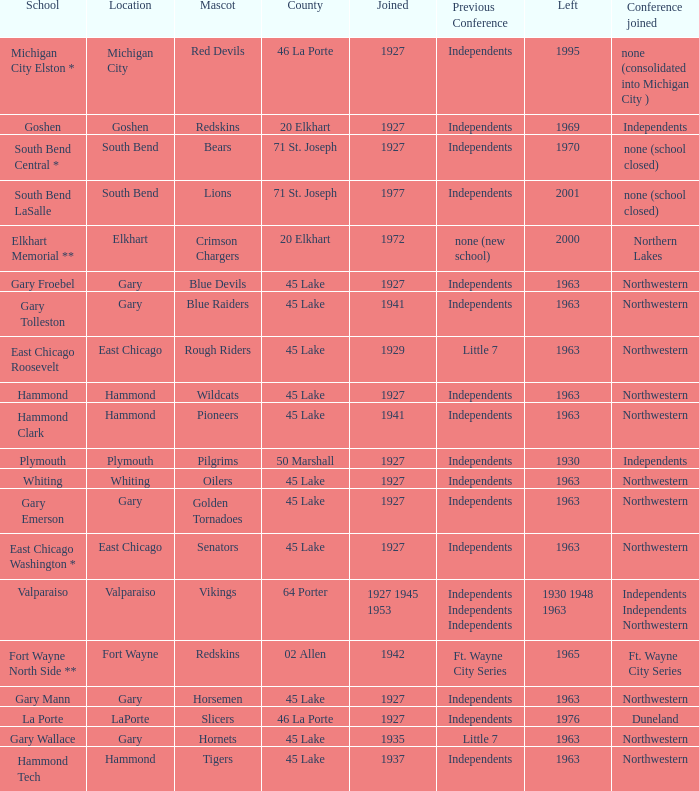When doeas Mascot of blue devils in Gary Froebel School? 1927.0. 